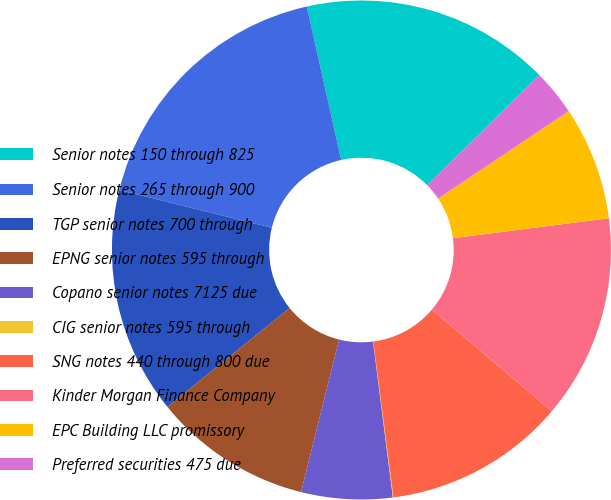Convert chart to OTSL. <chart><loc_0><loc_0><loc_500><loc_500><pie_chart><fcel>Senior notes 150 through 825<fcel>Senior notes 265 through 900<fcel>TGP senior notes 700 through<fcel>EPNG senior notes 595 through<fcel>Copano senior notes 7125 due<fcel>CIG senior notes 595 through<fcel>SNG notes 440 through 800 due<fcel>Kinder Morgan Finance Company<fcel>EPC Building LLC promissory<fcel>Preferred securities 475 due<nl><fcel>16.15%<fcel>17.62%<fcel>14.69%<fcel>10.29%<fcel>5.9%<fcel>0.04%<fcel>11.76%<fcel>13.22%<fcel>7.36%<fcel>2.97%<nl></chart> 